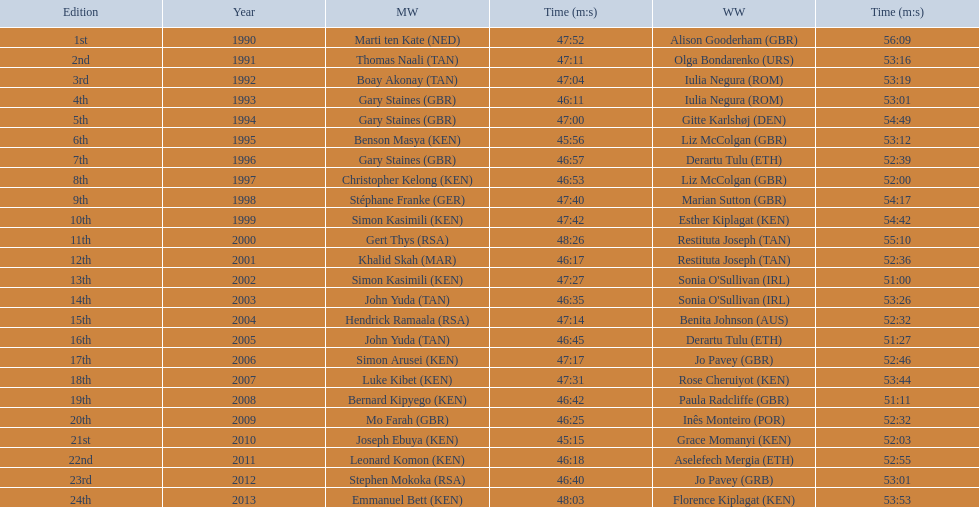What place did sonia o'sullivan finish in 2003? 14th. How long did it take her to finish? 53:26. Help me parse the entirety of this table. {'header': ['Edition', 'Year', 'MW', 'Time (m:s)', 'WW', 'Time (m:s)'], 'rows': [['1st', '1990', 'Marti ten Kate\xa0(NED)', '47:52', 'Alison Gooderham\xa0(GBR)', '56:09'], ['2nd', '1991', 'Thomas Naali\xa0(TAN)', '47:11', 'Olga Bondarenko\xa0(URS)', '53:16'], ['3rd', '1992', 'Boay Akonay\xa0(TAN)', '47:04', 'Iulia Negura\xa0(ROM)', '53:19'], ['4th', '1993', 'Gary Staines\xa0(GBR)', '46:11', 'Iulia Negura\xa0(ROM)', '53:01'], ['5th', '1994', 'Gary Staines\xa0(GBR)', '47:00', 'Gitte Karlshøj\xa0(DEN)', '54:49'], ['6th', '1995', 'Benson Masya\xa0(KEN)', '45:56', 'Liz McColgan\xa0(GBR)', '53:12'], ['7th', '1996', 'Gary Staines\xa0(GBR)', '46:57', 'Derartu Tulu\xa0(ETH)', '52:39'], ['8th', '1997', 'Christopher Kelong\xa0(KEN)', '46:53', 'Liz McColgan\xa0(GBR)', '52:00'], ['9th', '1998', 'Stéphane Franke\xa0(GER)', '47:40', 'Marian Sutton\xa0(GBR)', '54:17'], ['10th', '1999', 'Simon Kasimili\xa0(KEN)', '47:42', 'Esther Kiplagat\xa0(KEN)', '54:42'], ['11th', '2000', 'Gert Thys\xa0(RSA)', '48:26', 'Restituta Joseph\xa0(TAN)', '55:10'], ['12th', '2001', 'Khalid Skah\xa0(MAR)', '46:17', 'Restituta Joseph\xa0(TAN)', '52:36'], ['13th', '2002', 'Simon Kasimili\xa0(KEN)', '47:27', "Sonia O'Sullivan\xa0(IRL)", '51:00'], ['14th', '2003', 'John Yuda\xa0(TAN)', '46:35', "Sonia O'Sullivan\xa0(IRL)", '53:26'], ['15th', '2004', 'Hendrick Ramaala\xa0(RSA)', '47:14', 'Benita Johnson\xa0(AUS)', '52:32'], ['16th', '2005', 'John Yuda\xa0(TAN)', '46:45', 'Derartu Tulu\xa0(ETH)', '51:27'], ['17th', '2006', 'Simon Arusei\xa0(KEN)', '47:17', 'Jo Pavey\xa0(GBR)', '52:46'], ['18th', '2007', 'Luke Kibet\xa0(KEN)', '47:31', 'Rose Cheruiyot\xa0(KEN)', '53:44'], ['19th', '2008', 'Bernard Kipyego\xa0(KEN)', '46:42', 'Paula Radcliffe\xa0(GBR)', '51:11'], ['20th', '2009', 'Mo Farah\xa0(GBR)', '46:25', 'Inês Monteiro\xa0(POR)', '52:32'], ['21st', '2010', 'Joseph Ebuya\xa0(KEN)', '45:15', 'Grace Momanyi\xa0(KEN)', '52:03'], ['22nd', '2011', 'Leonard Komon\xa0(KEN)', '46:18', 'Aselefech Mergia\xa0(ETH)', '52:55'], ['23rd', '2012', 'Stephen Mokoka\xa0(RSA)', '46:40', 'Jo Pavey\xa0(GRB)', '53:01'], ['24th', '2013', 'Emmanuel Bett\xa0(KEN)', '48:03', 'Florence Kiplagat\xa0(KEN)', '53:53']]} 